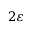Convert formula to latex. <formula><loc_0><loc_0><loc_500><loc_500>2 \varepsilon</formula> 